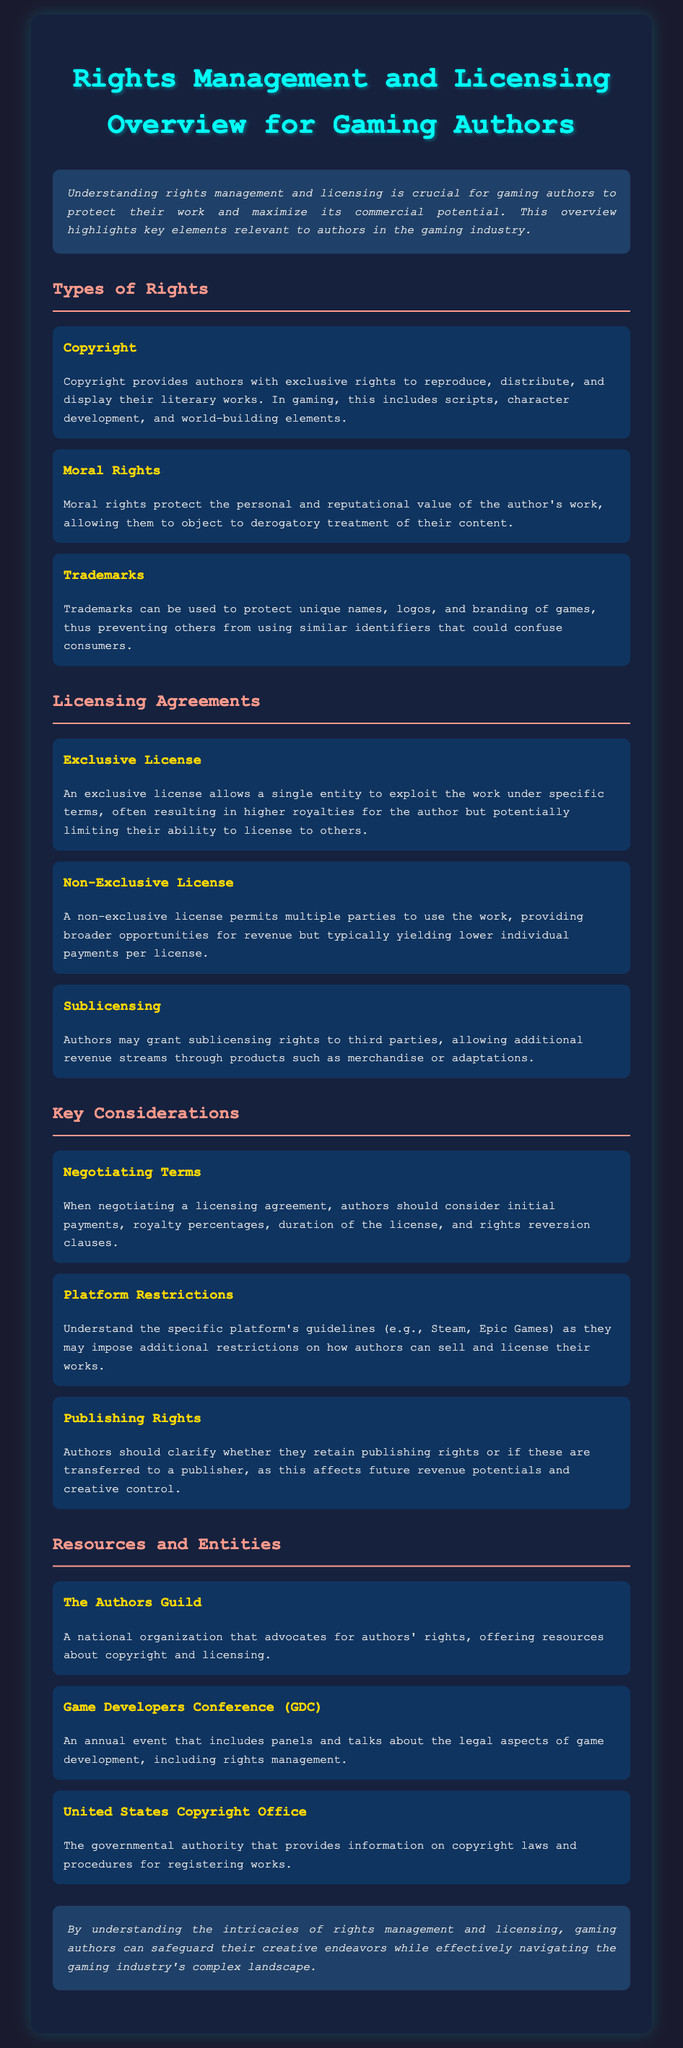What are the types of rights mentioned? The document lists several types of rights including Copyright, Moral Rights, and Trademarks.
Answer: Copyright, Moral Rights, Trademarks What organization advocates for authors' rights? The document mentions The Authors Guild as an organization that advocates for authors' rights.
Answer: The Authors Guild What is an exclusive license? An exclusive license allows a single entity to exploit the work under specific terms.
Answer: Single entity What do authors need to consider when negotiating a licensing agreement? Authors should consider initial payments, royalty percentages, duration of the license, and rights reversion clauses when negotiating a licensing agreement.
Answer: Initial payments, royalty percentages, duration of the license, rights reversion clauses What is the role of the United States Copyright Office? The document states that the United States Copyright Office provides information on copyright laws and registration procedures.
Answer: Information on copyright laws What are the potential benefits of a non-exclusive license? A non-exclusive license permits multiple parties to use the work and provides broader opportunities for revenue.
Answer: Broader opportunities for revenue What does the introduction emphasize about rights management? The introduction emphasizes that understanding rights management is crucial for gaming authors to protect their work and maximize its commercial potential.
Answer: Protect their work, maximize commercial potential What is a key consideration regarding platform restrictions? Authors should understand the specific platform's guidelines as they may impose additional restrictions on sales and licensing.
Answer: Specific platform's guidelines What annual event includes panels on legal aspects of game development? The document mentions the Game Developers Conference (GDC) as an event that includes panels on legal aspects.
Answer: Game Developers Conference (GDC) 